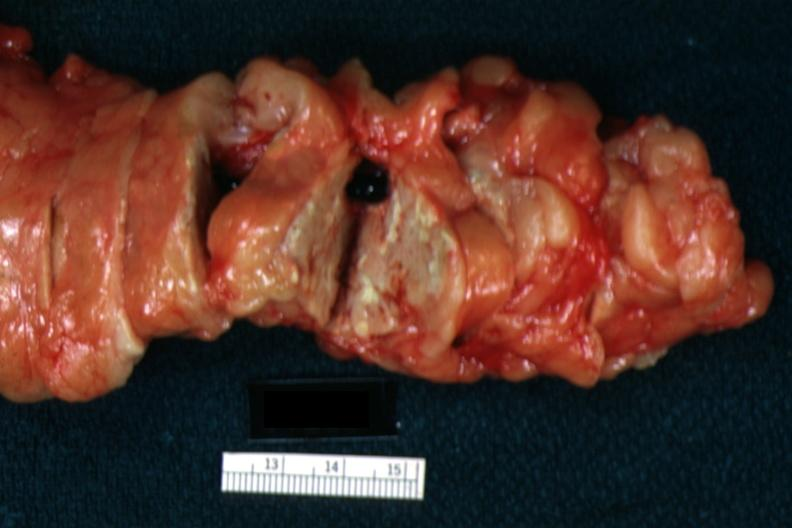what is present?
Answer the question using a single word or phrase. Shock 